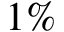<formula> <loc_0><loc_0><loc_500><loc_500>1 \%</formula> 